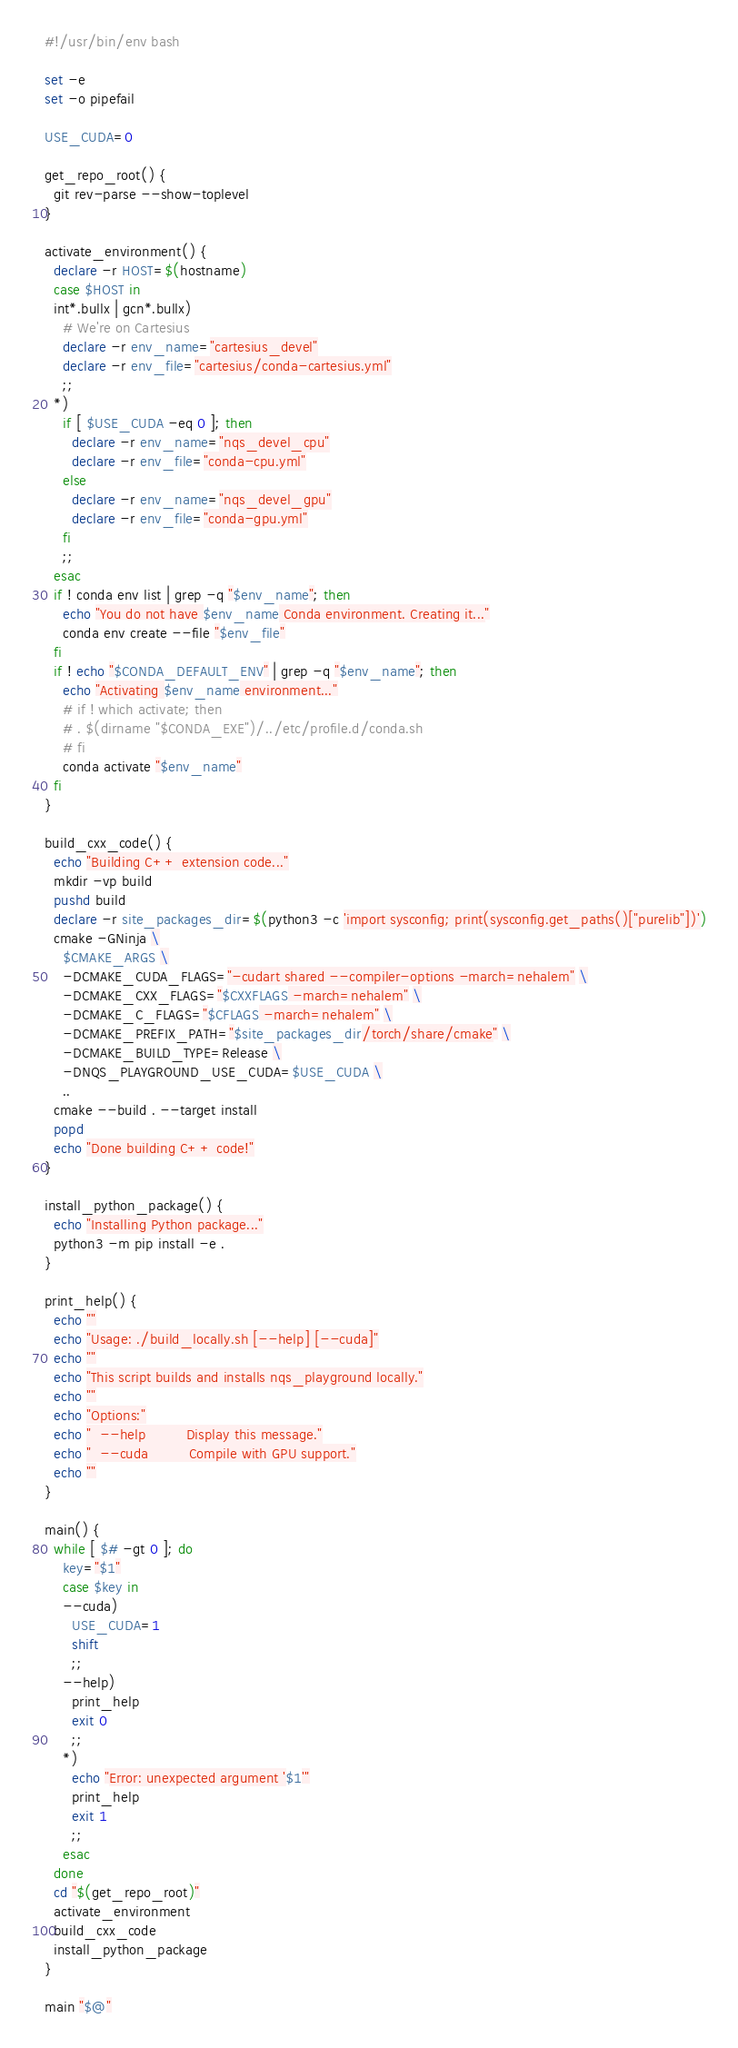<code> <loc_0><loc_0><loc_500><loc_500><_Bash_>#!/usr/bin/env bash

set -e
set -o pipefail

USE_CUDA=0

get_repo_root() {
  git rev-parse --show-toplevel
}

activate_environment() {
  declare -r HOST=$(hostname)
  case $HOST in
  int*.bullx | gcn*.bullx)
    # We're on Cartesius
    declare -r env_name="cartesius_devel"
    declare -r env_file="cartesius/conda-cartesius.yml"
    ;;
  *)
    if [ $USE_CUDA -eq 0 ]; then
      declare -r env_name="nqs_devel_cpu"
      declare -r env_file="conda-cpu.yml"
    else
      declare -r env_name="nqs_devel_gpu"
      declare -r env_file="conda-gpu.yml"
    fi
    ;;
  esac
  if ! conda env list | grep -q "$env_name"; then
    echo "You do not have $env_name Conda environment. Creating it..."
    conda env create --file "$env_file"
  fi
  if ! echo "$CONDA_DEFAULT_ENV" | grep -q "$env_name"; then
    echo "Activating $env_name environment..."
    # if ! which activate; then
    # . $(dirname "$CONDA_EXE")/../etc/profile.d/conda.sh
    # fi
    conda activate "$env_name"
  fi
}

build_cxx_code() {
  echo "Building C++ extension code..."
  mkdir -vp build
  pushd build
  declare -r site_packages_dir=$(python3 -c 'import sysconfig; print(sysconfig.get_paths()["purelib"])')
  cmake -GNinja \
    $CMAKE_ARGS \
    -DCMAKE_CUDA_FLAGS="-cudart shared --compiler-options -march=nehalem" \
    -DCMAKE_CXX_FLAGS="$CXXFLAGS -march=nehalem" \
    -DCMAKE_C_FLAGS="$CFLAGS -march=nehalem" \
    -DCMAKE_PREFIX_PATH="$site_packages_dir/torch/share/cmake" \
    -DCMAKE_BUILD_TYPE=Release \
    -DNQS_PLAYGROUND_USE_CUDA=$USE_CUDA \
    ..
  cmake --build . --target install
  popd
  echo "Done building C++ code!"
}

install_python_package() {
  echo "Installing Python package..."
  python3 -m pip install -e .
}

print_help() {
  echo ""
  echo "Usage: ./build_locally.sh [--help] [--cuda]"
  echo ""
  echo "This script builds and installs nqs_playground locally."
  echo ""
  echo "Options:"
  echo "  --help         Display this message."
  echo "  --cuda         Compile with GPU support."
  echo ""
}

main() {
  while [ $# -gt 0 ]; do
    key="$1"
    case $key in
    --cuda)
      USE_CUDA=1
      shift
      ;;
    --help)
      print_help
      exit 0
      ;;
    *)
      echo "Error: unexpected argument '$1'"
      print_help
      exit 1
      ;;
    esac
  done
  cd "$(get_repo_root)"
  activate_environment
  build_cxx_code
  install_python_package
}

main "$@"
</code> 